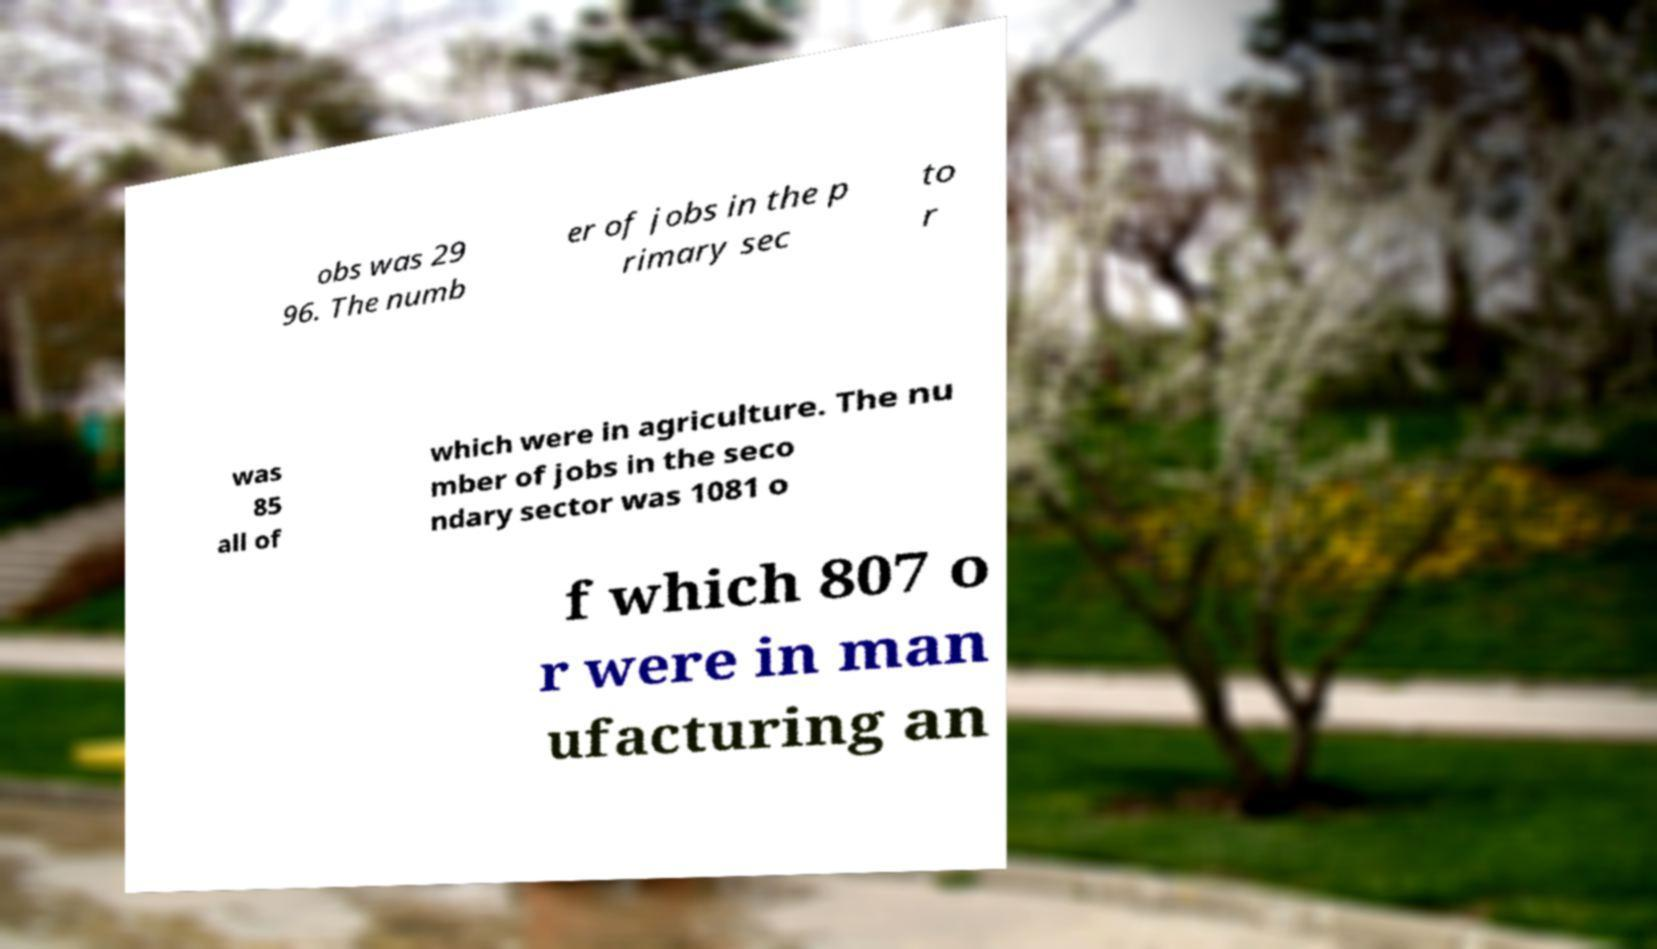Could you extract and type out the text from this image? obs was 29 96. The numb er of jobs in the p rimary sec to r was 85 all of which were in agriculture. The nu mber of jobs in the seco ndary sector was 1081 o f which 807 o r were in man ufacturing an 